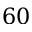Convert formula to latex. <formula><loc_0><loc_0><loc_500><loc_500>6 0</formula> 